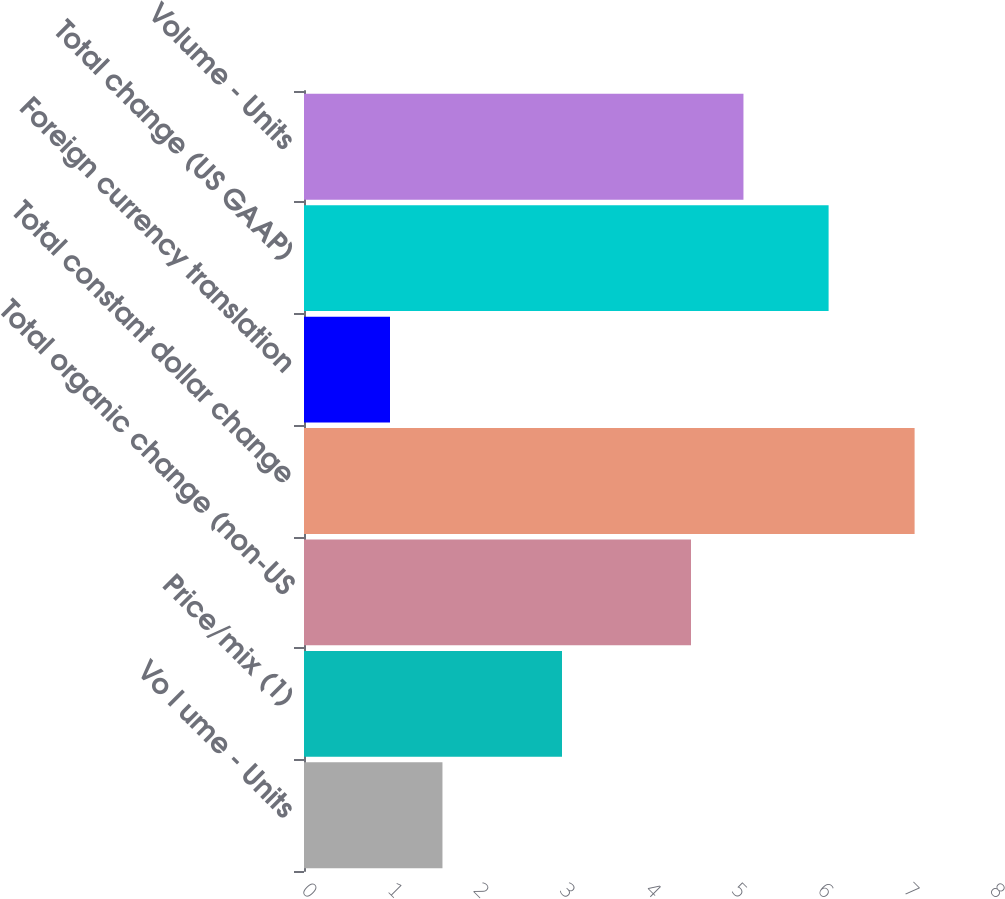Convert chart to OTSL. <chart><loc_0><loc_0><loc_500><loc_500><bar_chart><fcel>Vo l ume - Units<fcel>Price/mix (1)<fcel>Total organic change (non-US<fcel>Total constant dollar change<fcel>Foreign currency translation<fcel>Total change (US GAAP)<fcel>Volume - Units<nl><fcel>1.61<fcel>3<fcel>4.5<fcel>7.1<fcel>1<fcel>6.1<fcel>5.11<nl></chart> 